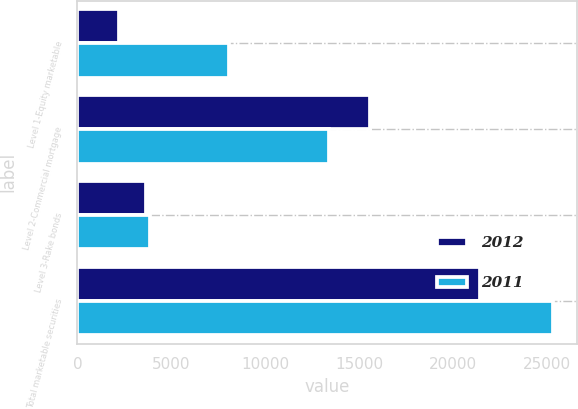<chart> <loc_0><loc_0><loc_500><loc_500><stacked_bar_chart><ecel><fcel>Level 1-Equity marketable<fcel>Level 2-Commercial mortgage<fcel>Level 3-Rake bonds<fcel>Total marketable securities<nl><fcel>2012<fcel>2202<fcel>15575<fcel>3652<fcel>21429<nl><fcel>2011<fcel>8065<fcel>13369<fcel>3889<fcel>25323<nl></chart> 